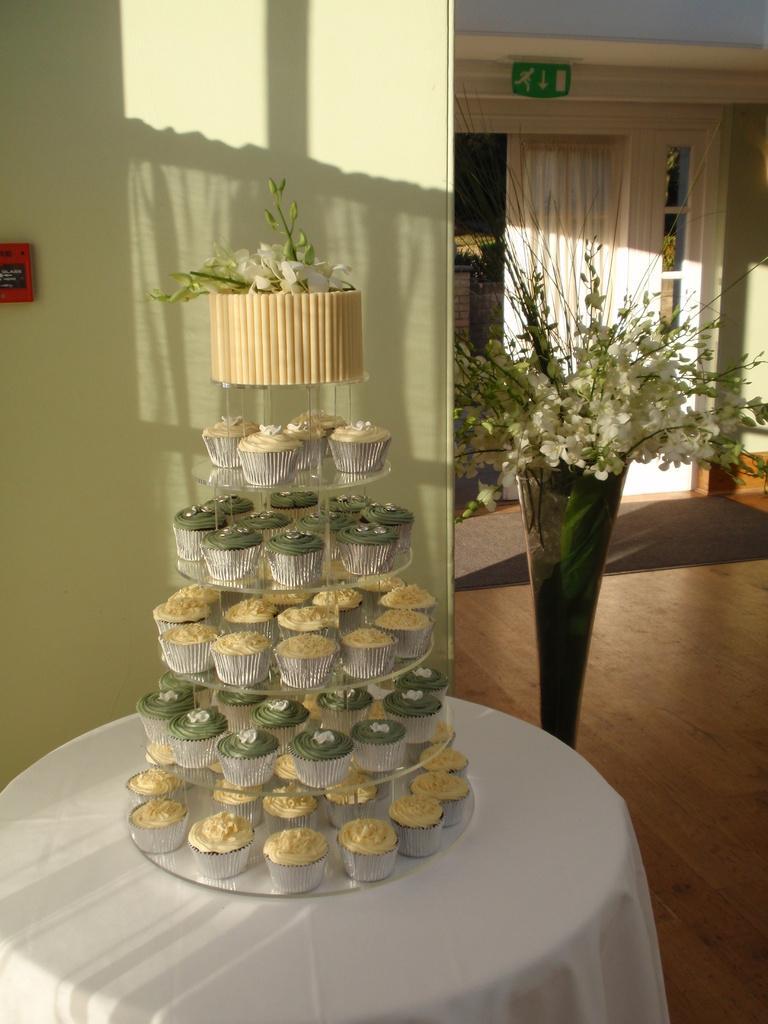Please provide a concise description of this image. In this image I can see a table which is white in color and on the table I can see number of cupcakes. In the background I can see a flower vase with cream colored flowers in it, the ceiling, the curtain, the wall and a green colored board. 